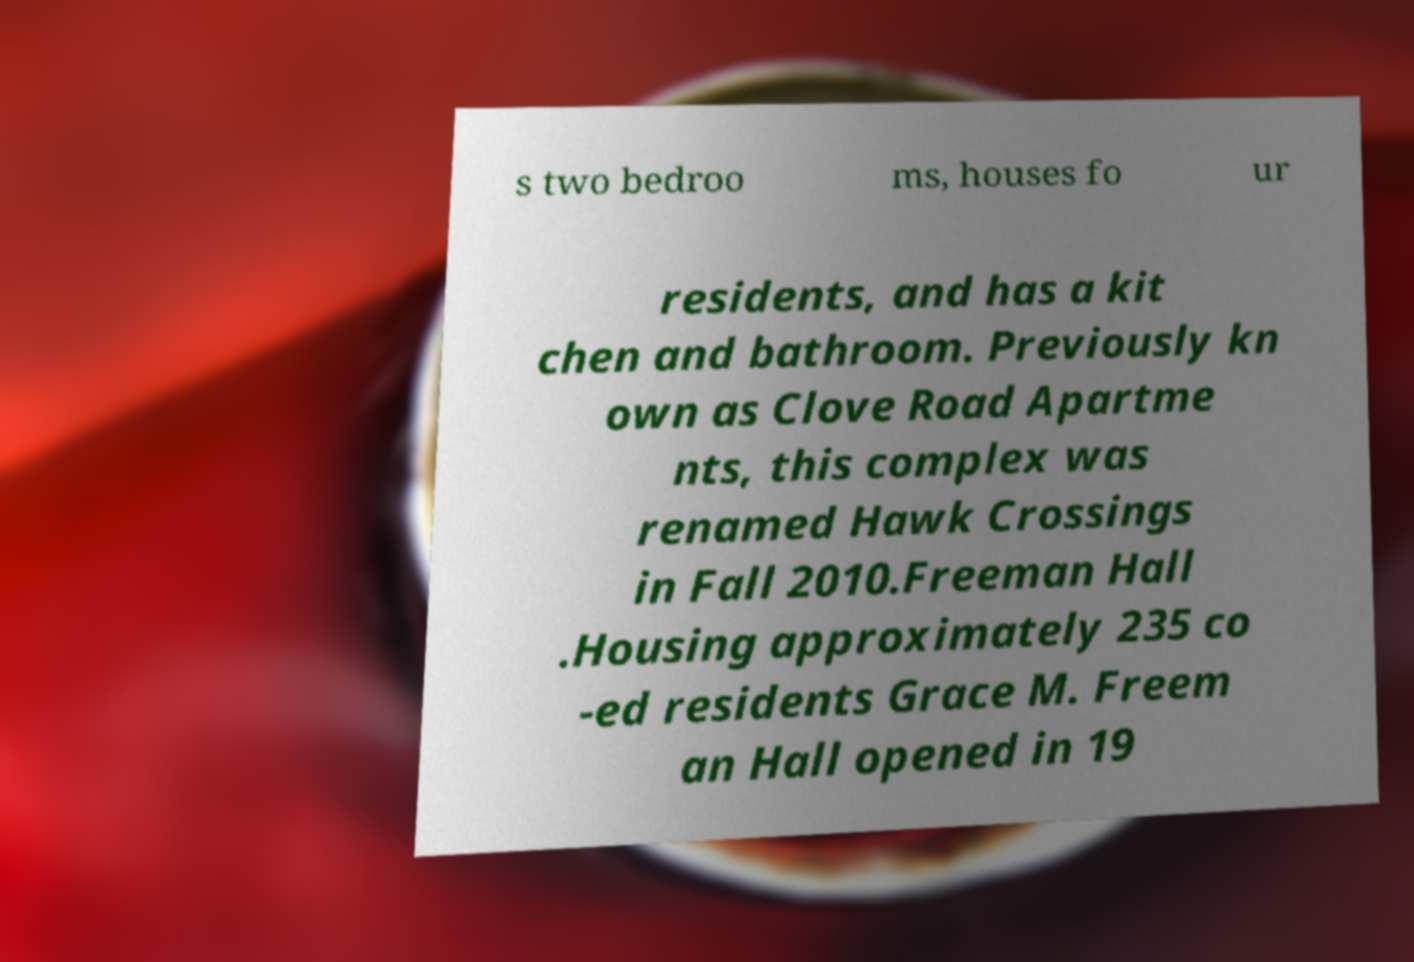I need the written content from this picture converted into text. Can you do that? s two bedroo ms, houses fo ur residents, and has a kit chen and bathroom. Previously kn own as Clove Road Apartme nts, this complex was renamed Hawk Crossings in Fall 2010.Freeman Hall .Housing approximately 235 co -ed residents Grace M. Freem an Hall opened in 19 